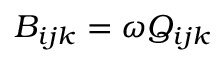<formula> <loc_0><loc_0><loc_500><loc_500>B _ { i j k } = \omega Q _ { i j k }</formula> 